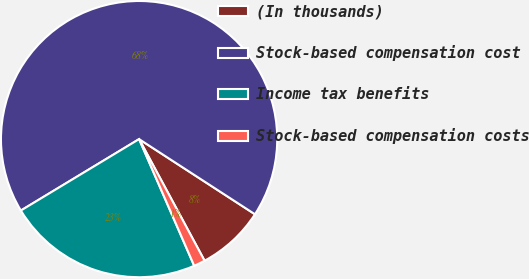<chart> <loc_0><loc_0><loc_500><loc_500><pie_chart><fcel>(In thousands)<fcel>Stock-based compensation cost<fcel>Income tax benefits<fcel>Stock-based compensation costs<nl><fcel>7.98%<fcel>67.8%<fcel>22.88%<fcel>1.33%<nl></chart> 